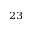<formula> <loc_0><loc_0><loc_500><loc_500>^ { 2 3 }</formula> 